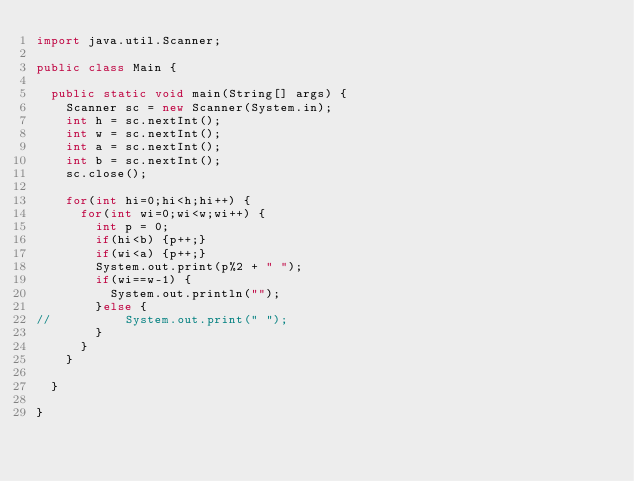Convert code to text. <code><loc_0><loc_0><loc_500><loc_500><_Java_>import java.util.Scanner;

public class Main {

	public static void main(String[] args) {
		Scanner sc = new Scanner(System.in);
		int h = sc.nextInt();
		int w = sc.nextInt();
		int a = sc.nextInt();
		int b = sc.nextInt();
		sc.close();
		
		for(int hi=0;hi<h;hi++) {
			for(int wi=0;wi<w;wi++) {
				int p = 0;
				if(hi<b) {p++;}
				if(wi<a) {p++;}
				System.out.print(p%2 + " ");
				if(wi==w-1) {
					System.out.println("");
				}else {
//					System.out.print(" ");
				}
			}
		}

	}

}
</code> 